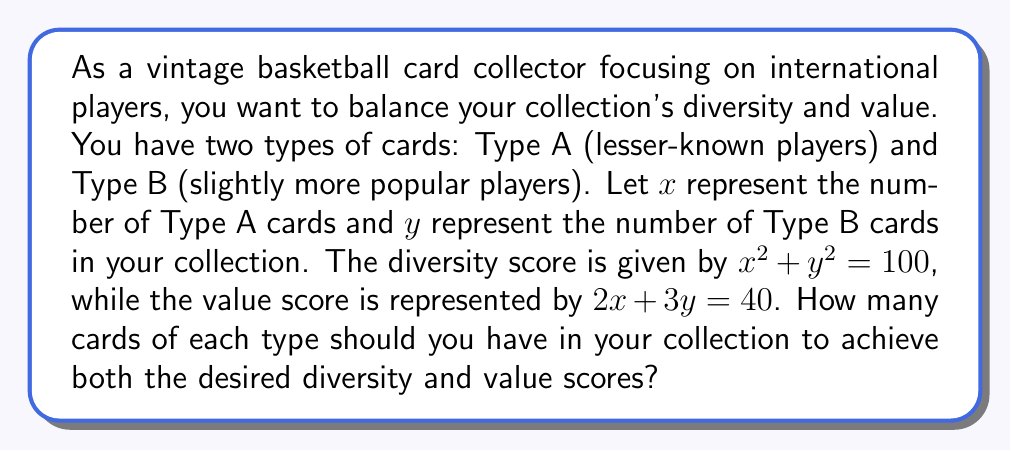What is the answer to this math problem? To solve this system of polynomial equations, we'll use the substitution method:

1) We have two equations:
   $$x^2 + y^2 = 100$$ (Diversity score)
   $$2x + 3y = 40$$ (Value score)

2) From the second equation, we can express $x$ in terms of $y$:
   $$x = 20 - \frac{3y}{2}$$

3) Substitute this expression for $x$ into the first equation:
   $$(20 - \frac{3y}{2})^2 + y^2 = 100$$

4) Expand the squared term:
   $$400 - 60y + \frac{9y^2}{4} + y^2 = 100$$

5) Simplify:
   $$400 - 60y + \frac{13y^2}{4} = 100$$

6) Subtract 100 from both sides:
   $$300 - 60y + \frac{13y^2}{4} = 0$$

7) Multiply all terms by 4 to eliminate fractions:
   $$1200 - 240y + 13y^2 = 0$$

8) Rearrange into standard quadratic form:
   $$13y^2 - 240y + 1200 = 0$$

9) Solve using the quadratic formula: $y = \frac{-b \pm \sqrt{b^2 - 4ac}}{2a}$
   $$y = \frac{240 \pm \sqrt{240^2 - 4(13)(1200)}}{2(13)}$$
   $$y = \frac{240 \pm \sqrt{57600 - 62400}}{26}$$
   $$y = \frac{240 \pm \sqrt{-4800}}{26}$$

10) Since we can't have an imaginary solution for the number of cards, the only real solution is:
    $$y = \frac{240}{26} = \frac{120}{13} \approx 9.23$$

11) Round to the nearest whole number: $y = 9$

12) Substitute this value back into the equation from step 2 to find $x$:
    $$x = 20 - \frac{3(9)}{2} = 20 - \frac{27}{2} = \frac{13}{2} = 6.5$$

13) Round to the nearest whole number: $x = 7$

Therefore, you should have 7 Type A cards and 9 Type B cards in your collection.
Answer: 7 Type A cards, 9 Type B cards 